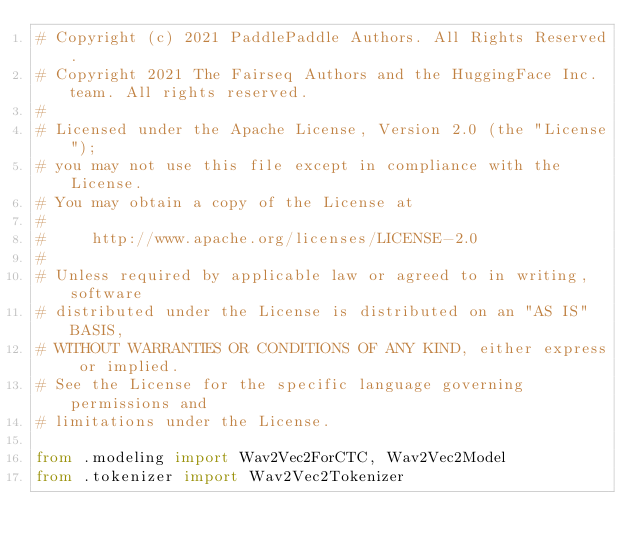<code> <loc_0><loc_0><loc_500><loc_500><_Python_># Copyright (c) 2021 PaddlePaddle Authors. All Rights Reserved.
# Copyright 2021 The Fairseq Authors and the HuggingFace Inc. team. All rights reserved.
#
# Licensed under the Apache License, Version 2.0 (the "License");
# you may not use this file except in compliance with the License.
# You may obtain a copy of the License at
#
#     http://www.apache.org/licenses/LICENSE-2.0
#
# Unless required by applicable law or agreed to in writing, software
# distributed under the License is distributed on an "AS IS" BASIS,
# WITHOUT WARRANTIES OR CONDITIONS OF ANY KIND, either express or implied.
# See the License for the specific language governing permissions and
# limitations under the License.

from .modeling import Wav2Vec2ForCTC, Wav2Vec2Model
from .tokenizer import Wav2Vec2Tokenizer
</code> 